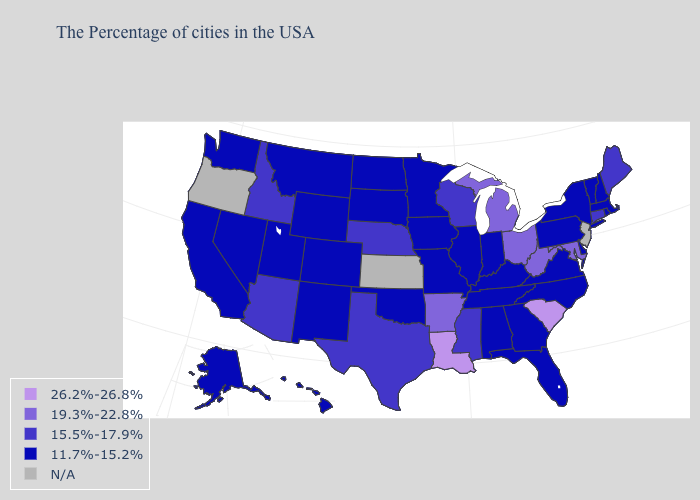What is the value of Wisconsin?
Short answer required. 15.5%-17.9%. What is the value of Utah?
Write a very short answer. 11.7%-15.2%. Name the states that have a value in the range 11.7%-15.2%?
Quick response, please. Massachusetts, Rhode Island, New Hampshire, Vermont, New York, Delaware, Pennsylvania, Virginia, North Carolina, Florida, Georgia, Kentucky, Indiana, Alabama, Tennessee, Illinois, Missouri, Minnesota, Iowa, Oklahoma, South Dakota, North Dakota, Wyoming, Colorado, New Mexico, Utah, Montana, Nevada, California, Washington, Alaska, Hawaii. What is the highest value in the USA?
Be succinct. 26.2%-26.8%. Among the states that border Pennsylvania , which have the highest value?
Concise answer only. Maryland, West Virginia, Ohio. Name the states that have a value in the range 15.5%-17.9%?
Be succinct. Maine, Connecticut, Wisconsin, Mississippi, Nebraska, Texas, Arizona, Idaho. Among the states that border Oregon , does Washington have the lowest value?
Write a very short answer. Yes. Does Louisiana have the highest value in the USA?
Short answer required. Yes. Name the states that have a value in the range 19.3%-22.8%?
Write a very short answer. Maryland, West Virginia, Ohio, Michigan, Arkansas. What is the value of Arkansas?
Concise answer only. 19.3%-22.8%. Among the states that border Iowa , does Wisconsin have the lowest value?
Write a very short answer. No. Among the states that border Georgia , which have the highest value?
Concise answer only. South Carolina. How many symbols are there in the legend?
Be succinct. 5. What is the highest value in the USA?
Quick response, please. 26.2%-26.8%. 